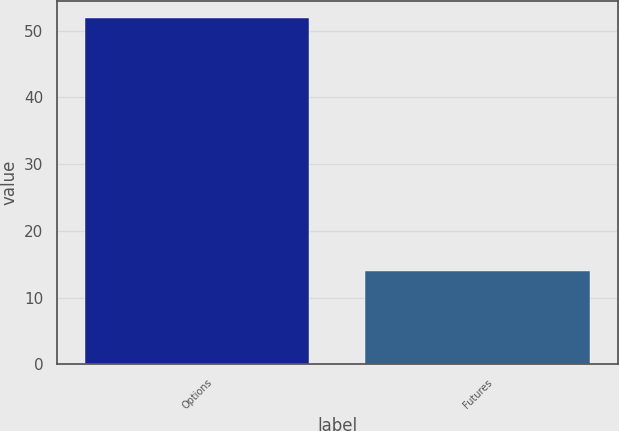Convert chart. <chart><loc_0><loc_0><loc_500><loc_500><bar_chart><fcel>Options<fcel>Futures<nl><fcel>51.9<fcel>14<nl></chart> 